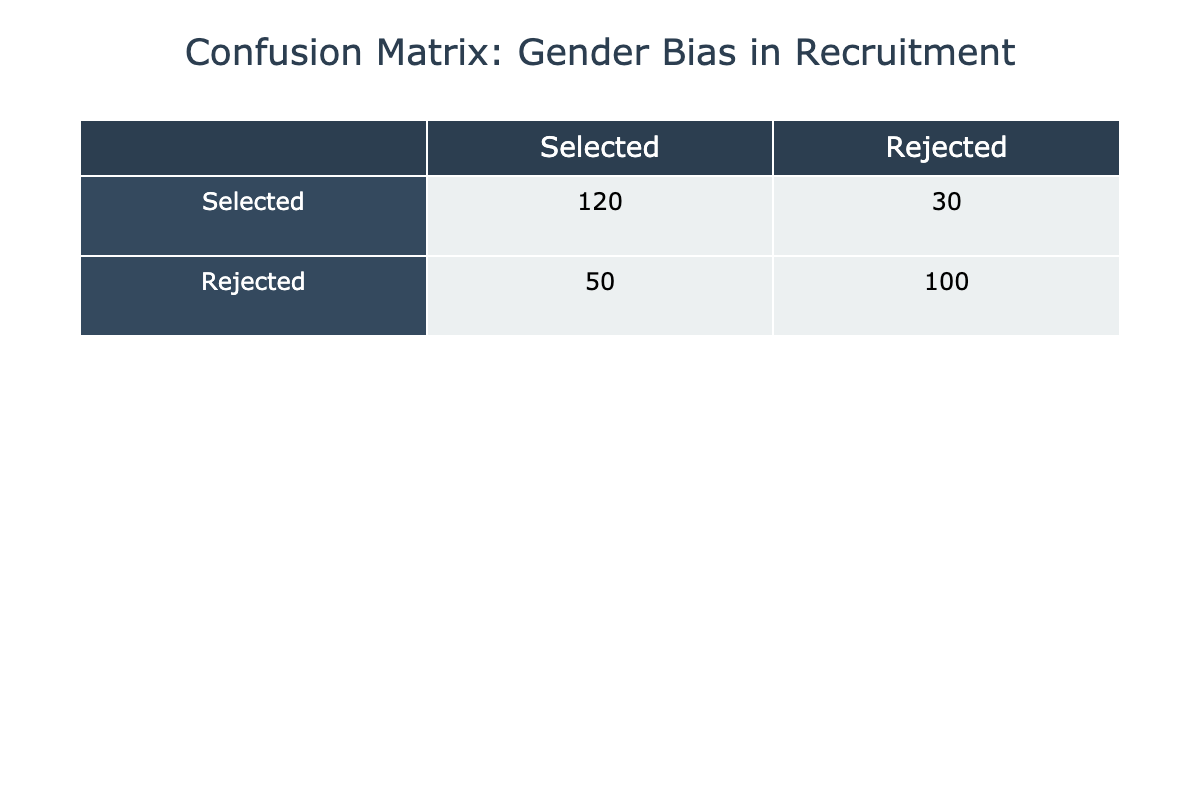What is the number of candidates selected? The table shows that 120 candidates were selected, which is the value in the "Selected" row under the "Selected" column.
Answer: 120 What is the total number of candidates rejected? To find the total number of candidates rejected, we add the values in the "Rejected" row: 50 (Rejected, Selected) + 100 (Rejected, Rejected) = 150.
Answer: 150 Is the number of selected candidates greater than the number of rejected candidates? The table indicates that 120 candidates were selected and 150 candidates were rejected. Since 120 is less than 150, the answer is no.
Answer: No What is the proportion of selected candidates to the total number of candidates? The total number of candidates is the sum of all values in the table: 120 + 30 + 50 + 100 = 300. Proportion of selected candidates is 120 (Selected) / 300 (Total) = 0.4, or 40%.
Answer: 0.4 What is the difference between the number of rejected candidates and the number of selected candidates? The number of rejected candidates is 150, and the number of selected candidates is 120. The difference is 150 - 120 = 30.
Answer: 30 What percentage of selected candidates were rejected after the selection process? The number of rejected candidates after selection is 30. To find the percentage, divide the rejected candidates by the total selected candidates: (30 / 120) * 100 = 25%.
Answer: 25% What is the average number of candidates selected or rejected based on the table? The sums for each category are 120 (Selected) + 30 (Rejected) + 50 (Rejected, Selected) + 100 (Rejected, Rejected) = 300 candidates in total. The average is thus calculated as 300 / 4 (total categories) = 75.
Answer: 75 If 50 more candidates were selected, how would that affect the total number of selected candidates? If 50 more candidates were selected, the total would increase to 120 (current selected) + 50 (additional) = 170.
Answer: 170 What can be inferred about gender bias in recruitment if a higher number of candidates are rejected rather than selected? A higher number of rejected candidates versus selected ones may suggest there could exist hidden biases in recruitment processes impacting selections. This inference may indicate potential gender bias if the rejected candidates are primarily of a specific gender.
Answer: Potential bias suggested 